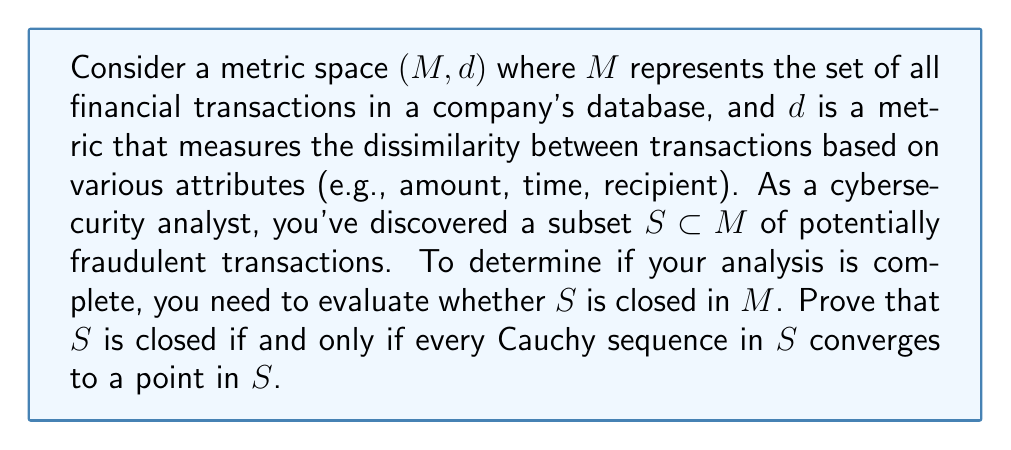Show me your answer to this math problem. To prove that $S$ is closed if and only if every Cauchy sequence in $S$ converges to a point in $S$, we need to show both directions of the implication.

1. First, let's prove that if $S$ is closed, then every Cauchy sequence in $S$ converges to a point in $S$.

   Assume $S$ is closed and let $(x_n)$ be a Cauchy sequence in $S$. Since $M$ is a metric space, it is complete, so $(x_n)$ converges to some point $x \in M$. We need to show that $x \in S$.

   Since $S$ is closed, it contains all of its limit points. For any $\epsilon > 0$, there exists an $N \in \mathbb{N}$ such that for all $n \geq N$, $d(x_n, x) < \epsilon$. This means $x$ is a limit point of $S$. Therefore, $x \in S$.

2. Now, let's prove the converse: if every Cauchy sequence in $S$ converges to a point in $S$, then $S$ is closed.

   We will prove this by contradiction. Assume that every Cauchy sequence in $S$ converges to a point in $S$, but $S$ is not closed. This means there exists a limit point $y$ of $S$ that is not in $S$.

   Since $y$ is a limit point of $S$, for every $\epsilon > 0$, there exists a point $x \in S$ such that $d(x, y) < \epsilon$. We can construct a sequence $(y_n)$ in $S$ where $d(y_n, y) < \frac{1}{n}$ for all $n \in \mathbb{N}$.

   This sequence $(y_n)$ is Cauchy because for any $\epsilon > 0$, we can choose $N = \lceil \frac{2}{\epsilon} \rceil$, and then for $m, n \geq N$:

   $$d(y_m, y_n) \leq d(y_m, y) + d(y, y_n) < \frac{1}{m} + \frac{1}{n} \leq \frac{2}{N} \leq \epsilon$$

   By our assumption, this Cauchy sequence must converge to a point in $S$. However, $(y_n)$ clearly converges to $y$, which is not in $S$. This is a contradiction.

Therefore, we have proved both directions of the implication, showing that $S$ is closed if and only if every Cauchy sequence in $S$ converges to a point in $S$.
Answer: $S$ is closed if and only if every Cauchy sequence in $S$ converges to a point in $S$. 